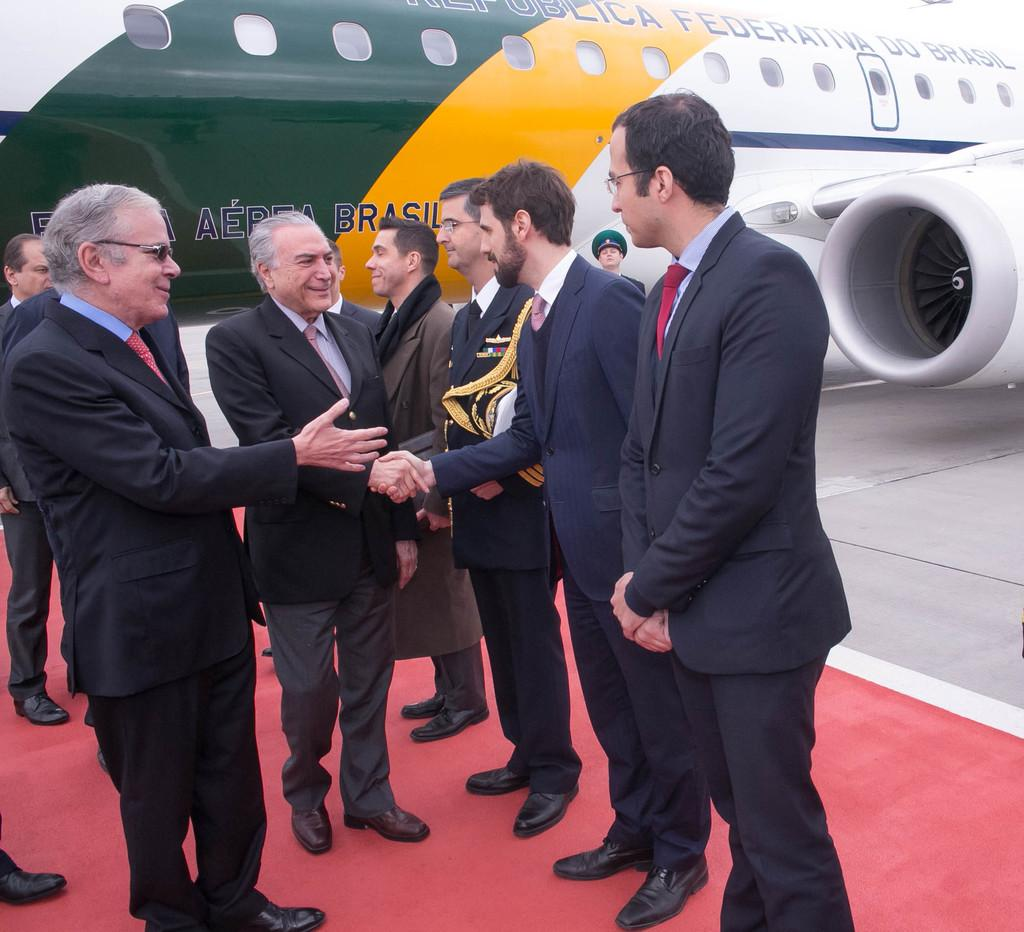What are the people in the image doing? The people in the image are shaking hands. Can you describe the action taking place between the people? The people are standing and shaking hands, which suggests they might be greeting each other or celebrating something. What can be seen in the background of the image? There is a plane visible in the background of the image. How many birds are in the flock flying over the people in the image? There is no flock of birds visible in the image; it only shows people shaking hands and a plane in the background. 